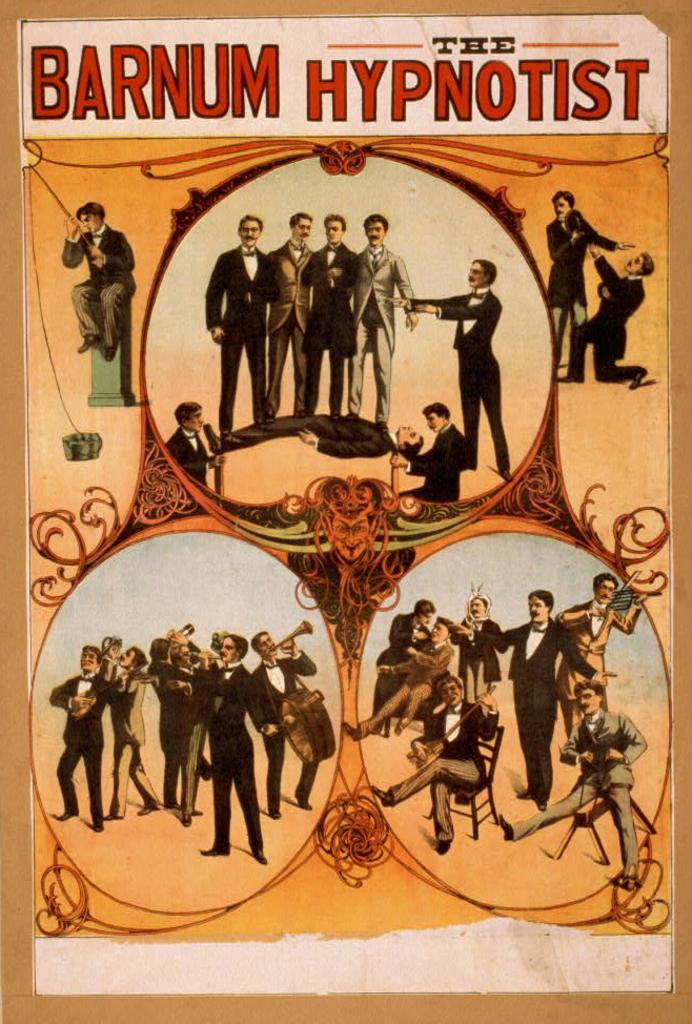Provide a one-sentence caption for the provided image. A vintage poster is the title "the Barnum hypnotist". 